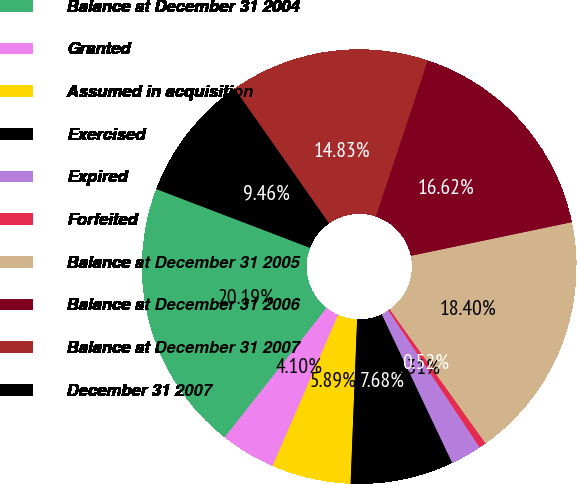Convert chart. <chart><loc_0><loc_0><loc_500><loc_500><pie_chart><fcel>Balance at December 31 2004<fcel>Granted<fcel>Assumed in acquisition<fcel>Exercised<fcel>Expired<fcel>Forfeited<fcel>Balance at December 31 2005<fcel>Balance at December 31 2006<fcel>Balance at December 31 2007<fcel>December 31 2007<nl><fcel>20.19%<fcel>4.1%<fcel>5.89%<fcel>7.68%<fcel>2.31%<fcel>0.52%<fcel>18.4%<fcel>16.62%<fcel>14.83%<fcel>9.46%<nl></chart> 